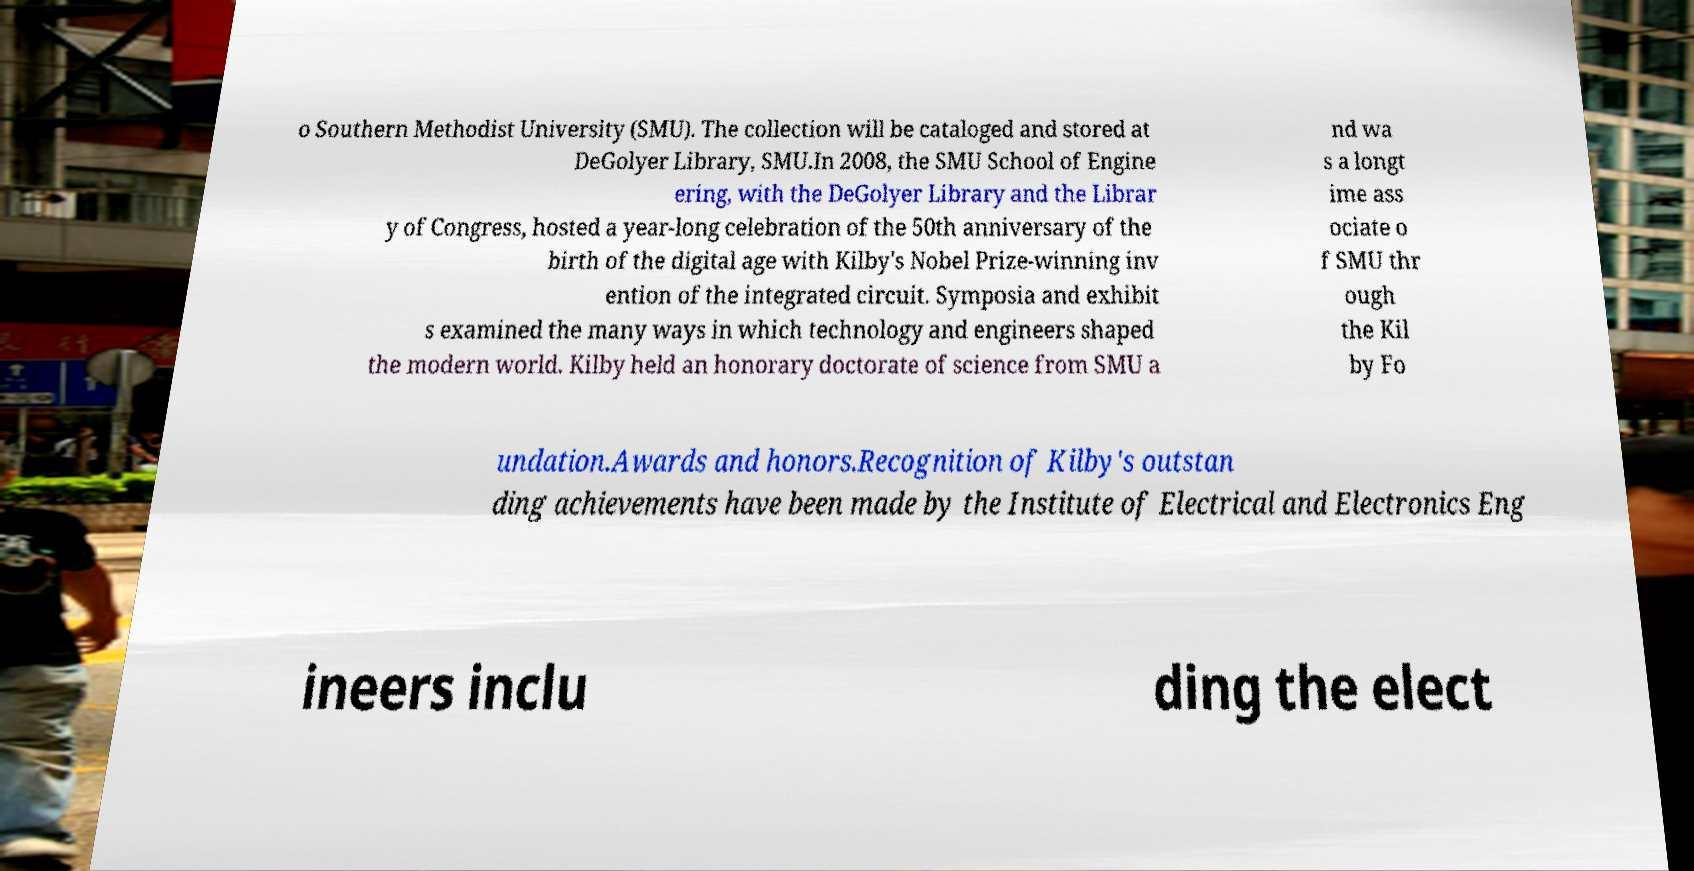There's text embedded in this image that I need extracted. Can you transcribe it verbatim? o Southern Methodist University (SMU). The collection will be cataloged and stored at DeGolyer Library, SMU.In 2008, the SMU School of Engine ering, with the DeGolyer Library and the Librar y of Congress, hosted a year-long celebration of the 50th anniversary of the birth of the digital age with Kilby's Nobel Prize-winning inv ention of the integrated circuit. Symposia and exhibit s examined the many ways in which technology and engineers shaped the modern world. Kilby held an honorary doctorate of science from SMU a nd wa s a longt ime ass ociate o f SMU thr ough the Kil by Fo undation.Awards and honors.Recognition of Kilby's outstan ding achievements have been made by the Institute of Electrical and Electronics Eng ineers inclu ding the elect 